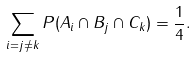<formula> <loc_0><loc_0><loc_500><loc_500>\sum _ { i = j \neq k } P ( A _ { i } \cap B _ { j } \cap C _ { k } ) = \frac { 1 } { 4 } .</formula> 